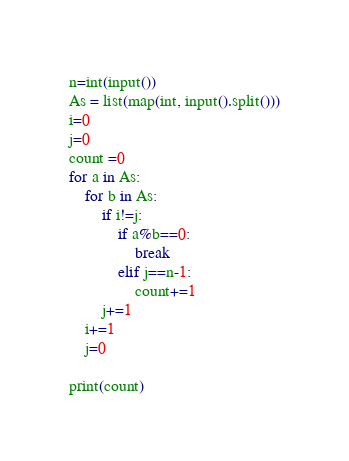<code> <loc_0><loc_0><loc_500><loc_500><_Python_>n=int(input())
As = list(map(int, input().split()))
i=0
j=0
count =0
for a in As:
    for b in As:
        if i!=j:
            if a%b==0:
                break
            elif j==n-1:
                count+=1
        j+=1
    i+=1
    j=0

print(count)</code> 